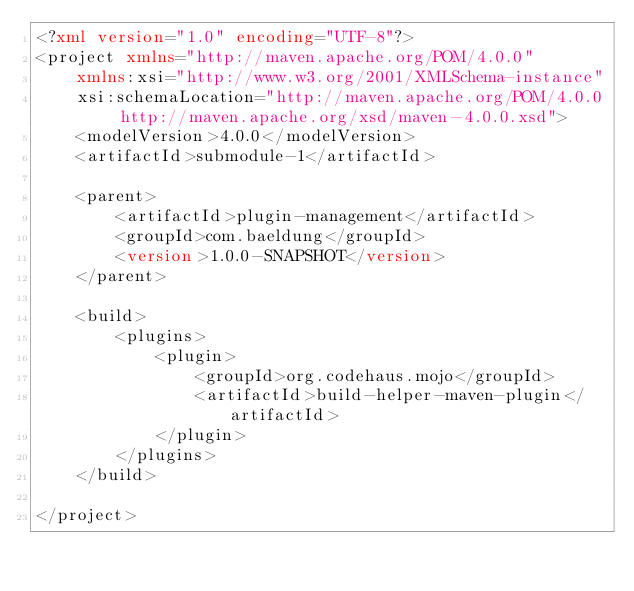<code> <loc_0><loc_0><loc_500><loc_500><_XML_><?xml version="1.0" encoding="UTF-8"?>
<project xmlns="http://maven.apache.org/POM/4.0.0"
    xmlns:xsi="http://www.w3.org/2001/XMLSchema-instance"
    xsi:schemaLocation="http://maven.apache.org/POM/4.0.0 http://maven.apache.org/xsd/maven-4.0.0.xsd">
    <modelVersion>4.0.0</modelVersion>
    <artifactId>submodule-1</artifactId>

    <parent>
        <artifactId>plugin-management</artifactId>
        <groupId>com.baeldung</groupId>
        <version>1.0.0-SNAPSHOT</version>
    </parent>

    <build>
        <plugins>
            <plugin>
                <groupId>org.codehaus.mojo</groupId>
                <artifactId>build-helper-maven-plugin</artifactId>
            </plugin>
        </plugins>
    </build>

</project></code> 